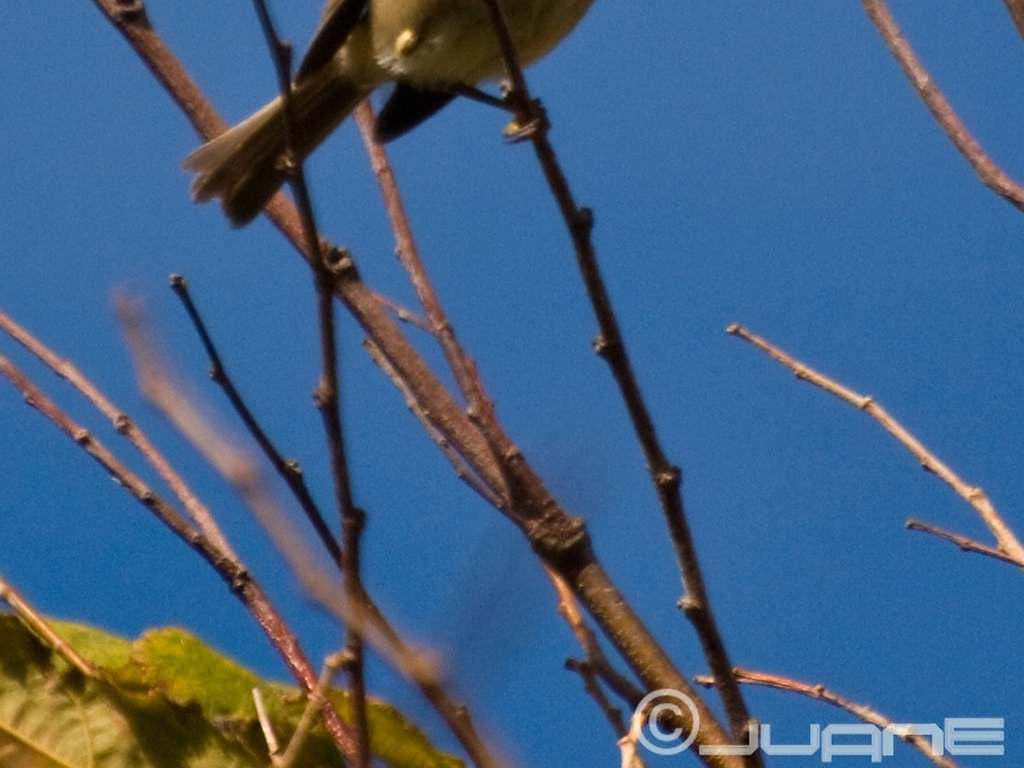What could be done to improve the quality of a photo like this? To enhance the photo's quality, stabilizing the camera using a tripod or a faster shutter speed could help reduce blurriness. Additionally, ensuring proper focus, perhaps by manually focusing on the subject or using a camera setting that tracks movement, would increase sharpness. Post-processing could also mitigate some of the noise to improve the overall clarity. 